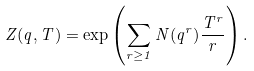<formula> <loc_0><loc_0><loc_500><loc_500>Z ( q , T ) = \exp \left ( \sum _ { r \geq 1 } N ( q ^ { r } ) \frac { T ^ { r } } { r } \right ) .</formula> 